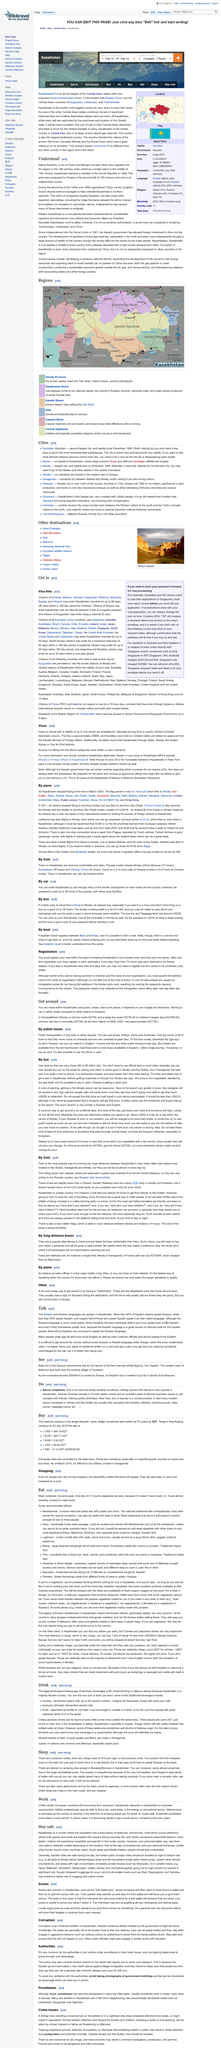List a handful of essential elements in this visual. Native Kazakhs are a unique mixture of Turkic and Mongol nomadic tribes who have a rich history and cultural heritage. Soviet citizens were actively encouraged to develop and nurture the vast pastures of Kazakhstan's northern regions, which were seen as a crucial source of livestock and agricultural production for the country as a whole. According to the article "Understand," Kazakhstan became a member of the Soviet Republic in 1936. 